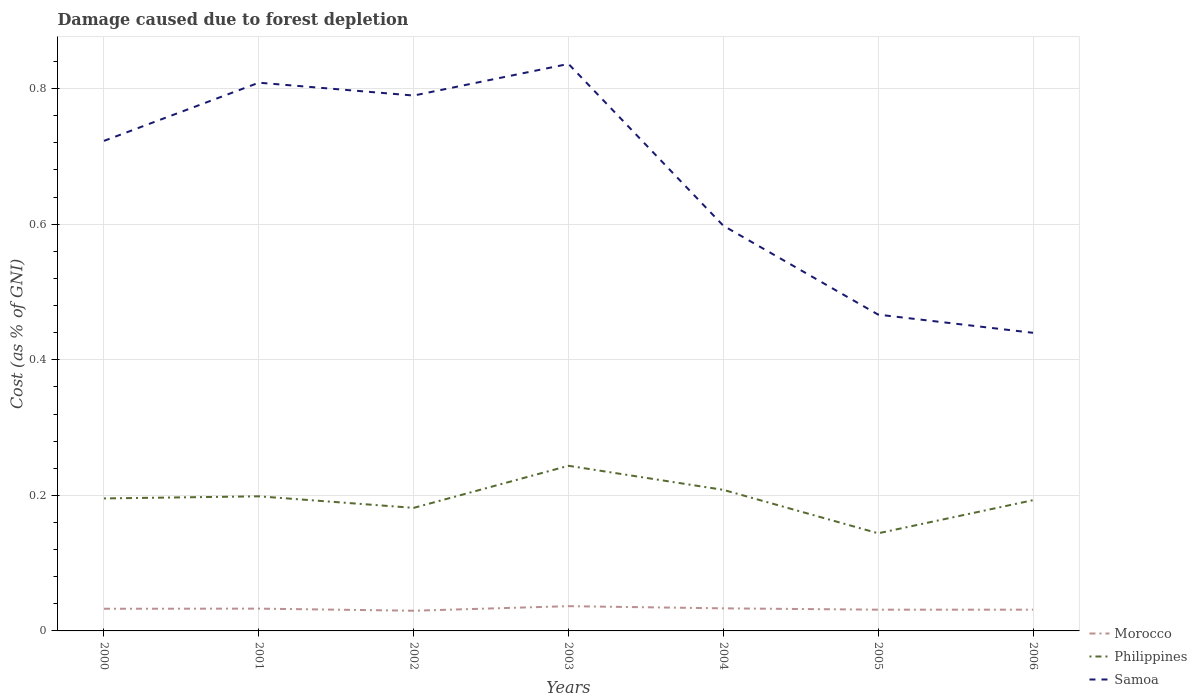Across all years, what is the maximum cost of damage caused due to forest depletion in Morocco?
Provide a succinct answer. 0.03. What is the total cost of damage caused due to forest depletion in Philippines in the graph?
Ensure brevity in your answer.  -0.05. What is the difference between the highest and the second highest cost of damage caused due to forest depletion in Philippines?
Provide a short and direct response. 0.1. What is the difference between the highest and the lowest cost of damage caused due to forest depletion in Morocco?
Offer a terse response. 4. How many years are there in the graph?
Give a very brief answer. 7. Does the graph contain any zero values?
Ensure brevity in your answer.  No. How many legend labels are there?
Keep it short and to the point. 3. How are the legend labels stacked?
Offer a very short reply. Vertical. What is the title of the graph?
Offer a terse response. Damage caused due to forest depletion. What is the label or title of the X-axis?
Ensure brevity in your answer.  Years. What is the label or title of the Y-axis?
Offer a very short reply. Cost (as % of GNI). What is the Cost (as % of GNI) of Morocco in 2000?
Keep it short and to the point. 0.03. What is the Cost (as % of GNI) in Philippines in 2000?
Keep it short and to the point. 0.2. What is the Cost (as % of GNI) in Samoa in 2000?
Ensure brevity in your answer.  0.72. What is the Cost (as % of GNI) in Morocco in 2001?
Your response must be concise. 0.03. What is the Cost (as % of GNI) in Philippines in 2001?
Your answer should be very brief. 0.2. What is the Cost (as % of GNI) in Samoa in 2001?
Your answer should be very brief. 0.81. What is the Cost (as % of GNI) in Morocco in 2002?
Provide a succinct answer. 0.03. What is the Cost (as % of GNI) in Philippines in 2002?
Your response must be concise. 0.18. What is the Cost (as % of GNI) in Samoa in 2002?
Your response must be concise. 0.79. What is the Cost (as % of GNI) of Morocco in 2003?
Make the answer very short. 0.04. What is the Cost (as % of GNI) of Philippines in 2003?
Provide a short and direct response. 0.24. What is the Cost (as % of GNI) of Samoa in 2003?
Offer a very short reply. 0.84. What is the Cost (as % of GNI) of Morocco in 2004?
Make the answer very short. 0.03. What is the Cost (as % of GNI) of Philippines in 2004?
Offer a terse response. 0.21. What is the Cost (as % of GNI) of Samoa in 2004?
Make the answer very short. 0.6. What is the Cost (as % of GNI) of Morocco in 2005?
Provide a succinct answer. 0.03. What is the Cost (as % of GNI) of Philippines in 2005?
Your answer should be very brief. 0.14. What is the Cost (as % of GNI) in Samoa in 2005?
Ensure brevity in your answer.  0.47. What is the Cost (as % of GNI) in Morocco in 2006?
Offer a very short reply. 0.03. What is the Cost (as % of GNI) in Philippines in 2006?
Your response must be concise. 0.19. What is the Cost (as % of GNI) of Samoa in 2006?
Ensure brevity in your answer.  0.44. Across all years, what is the maximum Cost (as % of GNI) of Morocco?
Give a very brief answer. 0.04. Across all years, what is the maximum Cost (as % of GNI) of Philippines?
Your answer should be compact. 0.24. Across all years, what is the maximum Cost (as % of GNI) in Samoa?
Keep it short and to the point. 0.84. Across all years, what is the minimum Cost (as % of GNI) in Morocco?
Your response must be concise. 0.03. Across all years, what is the minimum Cost (as % of GNI) in Philippines?
Keep it short and to the point. 0.14. Across all years, what is the minimum Cost (as % of GNI) of Samoa?
Keep it short and to the point. 0.44. What is the total Cost (as % of GNI) in Morocco in the graph?
Provide a short and direct response. 0.23. What is the total Cost (as % of GNI) of Philippines in the graph?
Provide a short and direct response. 1.36. What is the total Cost (as % of GNI) of Samoa in the graph?
Your response must be concise. 4.66. What is the difference between the Cost (as % of GNI) in Morocco in 2000 and that in 2001?
Offer a very short reply. -0. What is the difference between the Cost (as % of GNI) in Philippines in 2000 and that in 2001?
Ensure brevity in your answer.  -0. What is the difference between the Cost (as % of GNI) in Samoa in 2000 and that in 2001?
Offer a terse response. -0.09. What is the difference between the Cost (as % of GNI) in Morocco in 2000 and that in 2002?
Keep it short and to the point. 0. What is the difference between the Cost (as % of GNI) in Philippines in 2000 and that in 2002?
Make the answer very short. 0.01. What is the difference between the Cost (as % of GNI) in Samoa in 2000 and that in 2002?
Your response must be concise. -0.07. What is the difference between the Cost (as % of GNI) in Morocco in 2000 and that in 2003?
Offer a very short reply. -0. What is the difference between the Cost (as % of GNI) in Philippines in 2000 and that in 2003?
Offer a terse response. -0.05. What is the difference between the Cost (as % of GNI) of Samoa in 2000 and that in 2003?
Provide a short and direct response. -0.11. What is the difference between the Cost (as % of GNI) in Morocco in 2000 and that in 2004?
Offer a terse response. -0. What is the difference between the Cost (as % of GNI) of Philippines in 2000 and that in 2004?
Offer a very short reply. -0.01. What is the difference between the Cost (as % of GNI) in Samoa in 2000 and that in 2004?
Make the answer very short. 0.13. What is the difference between the Cost (as % of GNI) in Morocco in 2000 and that in 2005?
Offer a very short reply. 0. What is the difference between the Cost (as % of GNI) of Philippines in 2000 and that in 2005?
Offer a very short reply. 0.05. What is the difference between the Cost (as % of GNI) in Samoa in 2000 and that in 2005?
Ensure brevity in your answer.  0.26. What is the difference between the Cost (as % of GNI) of Morocco in 2000 and that in 2006?
Keep it short and to the point. 0. What is the difference between the Cost (as % of GNI) of Philippines in 2000 and that in 2006?
Give a very brief answer. 0. What is the difference between the Cost (as % of GNI) in Samoa in 2000 and that in 2006?
Your answer should be very brief. 0.28. What is the difference between the Cost (as % of GNI) of Morocco in 2001 and that in 2002?
Give a very brief answer. 0. What is the difference between the Cost (as % of GNI) in Philippines in 2001 and that in 2002?
Provide a succinct answer. 0.02. What is the difference between the Cost (as % of GNI) in Samoa in 2001 and that in 2002?
Provide a succinct answer. 0.02. What is the difference between the Cost (as % of GNI) in Morocco in 2001 and that in 2003?
Your answer should be compact. -0. What is the difference between the Cost (as % of GNI) in Philippines in 2001 and that in 2003?
Ensure brevity in your answer.  -0.04. What is the difference between the Cost (as % of GNI) in Samoa in 2001 and that in 2003?
Offer a terse response. -0.03. What is the difference between the Cost (as % of GNI) in Morocco in 2001 and that in 2004?
Your answer should be compact. -0. What is the difference between the Cost (as % of GNI) of Philippines in 2001 and that in 2004?
Give a very brief answer. -0.01. What is the difference between the Cost (as % of GNI) of Samoa in 2001 and that in 2004?
Your response must be concise. 0.21. What is the difference between the Cost (as % of GNI) of Morocco in 2001 and that in 2005?
Your response must be concise. 0. What is the difference between the Cost (as % of GNI) in Philippines in 2001 and that in 2005?
Provide a succinct answer. 0.05. What is the difference between the Cost (as % of GNI) of Samoa in 2001 and that in 2005?
Give a very brief answer. 0.34. What is the difference between the Cost (as % of GNI) in Morocco in 2001 and that in 2006?
Offer a terse response. 0. What is the difference between the Cost (as % of GNI) in Philippines in 2001 and that in 2006?
Your response must be concise. 0.01. What is the difference between the Cost (as % of GNI) in Samoa in 2001 and that in 2006?
Provide a short and direct response. 0.37. What is the difference between the Cost (as % of GNI) in Morocco in 2002 and that in 2003?
Your answer should be very brief. -0.01. What is the difference between the Cost (as % of GNI) of Philippines in 2002 and that in 2003?
Provide a succinct answer. -0.06. What is the difference between the Cost (as % of GNI) in Samoa in 2002 and that in 2003?
Provide a succinct answer. -0.05. What is the difference between the Cost (as % of GNI) in Morocco in 2002 and that in 2004?
Provide a succinct answer. -0. What is the difference between the Cost (as % of GNI) of Philippines in 2002 and that in 2004?
Ensure brevity in your answer.  -0.03. What is the difference between the Cost (as % of GNI) of Samoa in 2002 and that in 2004?
Make the answer very short. 0.19. What is the difference between the Cost (as % of GNI) in Morocco in 2002 and that in 2005?
Offer a terse response. -0. What is the difference between the Cost (as % of GNI) in Philippines in 2002 and that in 2005?
Offer a very short reply. 0.04. What is the difference between the Cost (as % of GNI) of Samoa in 2002 and that in 2005?
Offer a terse response. 0.32. What is the difference between the Cost (as % of GNI) of Morocco in 2002 and that in 2006?
Keep it short and to the point. -0. What is the difference between the Cost (as % of GNI) in Philippines in 2002 and that in 2006?
Keep it short and to the point. -0.01. What is the difference between the Cost (as % of GNI) of Morocco in 2003 and that in 2004?
Offer a very short reply. 0. What is the difference between the Cost (as % of GNI) in Philippines in 2003 and that in 2004?
Offer a very short reply. 0.04. What is the difference between the Cost (as % of GNI) of Samoa in 2003 and that in 2004?
Provide a short and direct response. 0.24. What is the difference between the Cost (as % of GNI) of Morocco in 2003 and that in 2005?
Offer a terse response. 0.01. What is the difference between the Cost (as % of GNI) in Philippines in 2003 and that in 2005?
Your answer should be very brief. 0.1. What is the difference between the Cost (as % of GNI) of Samoa in 2003 and that in 2005?
Keep it short and to the point. 0.37. What is the difference between the Cost (as % of GNI) of Morocco in 2003 and that in 2006?
Make the answer very short. 0.01. What is the difference between the Cost (as % of GNI) of Philippines in 2003 and that in 2006?
Your response must be concise. 0.05. What is the difference between the Cost (as % of GNI) of Samoa in 2003 and that in 2006?
Your answer should be compact. 0.4. What is the difference between the Cost (as % of GNI) in Morocco in 2004 and that in 2005?
Offer a very short reply. 0. What is the difference between the Cost (as % of GNI) of Philippines in 2004 and that in 2005?
Keep it short and to the point. 0.06. What is the difference between the Cost (as % of GNI) in Samoa in 2004 and that in 2005?
Make the answer very short. 0.13. What is the difference between the Cost (as % of GNI) of Morocco in 2004 and that in 2006?
Your answer should be compact. 0. What is the difference between the Cost (as % of GNI) in Philippines in 2004 and that in 2006?
Provide a short and direct response. 0.02. What is the difference between the Cost (as % of GNI) of Samoa in 2004 and that in 2006?
Your answer should be compact. 0.16. What is the difference between the Cost (as % of GNI) of Morocco in 2005 and that in 2006?
Ensure brevity in your answer.  0. What is the difference between the Cost (as % of GNI) in Philippines in 2005 and that in 2006?
Provide a succinct answer. -0.05. What is the difference between the Cost (as % of GNI) of Samoa in 2005 and that in 2006?
Your response must be concise. 0.03. What is the difference between the Cost (as % of GNI) of Morocco in 2000 and the Cost (as % of GNI) of Philippines in 2001?
Offer a terse response. -0.17. What is the difference between the Cost (as % of GNI) in Morocco in 2000 and the Cost (as % of GNI) in Samoa in 2001?
Make the answer very short. -0.78. What is the difference between the Cost (as % of GNI) of Philippines in 2000 and the Cost (as % of GNI) of Samoa in 2001?
Offer a very short reply. -0.61. What is the difference between the Cost (as % of GNI) of Morocco in 2000 and the Cost (as % of GNI) of Philippines in 2002?
Make the answer very short. -0.15. What is the difference between the Cost (as % of GNI) in Morocco in 2000 and the Cost (as % of GNI) in Samoa in 2002?
Your answer should be compact. -0.76. What is the difference between the Cost (as % of GNI) of Philippines in 2000 and the Cost (as % of GNI) of Samoa in 2002?
Your response must be concise. -0.59. What is the difference between the Cost (as % of GNI) in Morocco in 2000 and the Cost (as % of GNI) in Philippines in 2003?
Offer a very short reply. -0.21. What is the difference between the Cost (as % of GNI) in Morocco in 2000 and the Cost (as % of GNI) in Samoa in 2003?
Provide a short and direct response. -0.8. What is the difference between the Cost (as % of GNI) of Philippines in 2000 and the Cost (as % of GNI) of Samoa in 2003?
Give a very brief answer. -0.64. What is the difference between the Cost (as % of GNI) of Morocco in 2000 and the Cost (as % of GNI) of Philippines in 2004?
Offer a terse response. -0.18. What is the difference between the Cost (as % of GNI) of Morocco in 2000 and the Cost (as % of GNI) of Samoa in 2004?
Your answer should be very brief. -0.57. What is the difference between the Cost (as % of GNI) in Philippines in 2000 and the Cost (as % of GNI) in Samoa in 2004?
Your answer should be very brief. -0.4. What is the difference between the Cost (as % of GNI) of Morocco in 2000 and the Cost (as % of GNI) of Philippines in 2005?
Keep it short and to the point. -0.11. What is the difference between the Cost (as % of GNI) of Morocco in 2000 and the Cost (as % of GNI) of Samoa in 2005?
Provide a succinct answer. -0.43. What is the difference between the Cost (as % of GNI) in Philippines in 2000 and the Cost (as % of GNI) in Samoa in 2005?
Ensure brevity in your answer.  -0.27. What is the difference between the Cost (as % of GNI) of Morocco in 2000 and the Cost (as % of GNI) of Philippines in 2006?
Make the answer very short. -0.16. What is the difference between the Cost (as % of GNI) of Morocco in 2000 and the Cost (as % of GNI) of Samoa in 2006?
Provide a succinct answer. -0.41. What is the difference between the Cost (as % of GNI) in Philippines in 2000 and the Cost (as % of GNI) in Samoa in 2006?
Keep it short and to the point. -0.24. What is the difference between the Cost (as % of GNI) in Morocco in 2001 and the Cost (as % of GNI) in Philippines in 2002?
Your answer should be very brief. -0.15. What is the difference between the Cost (as % of GNI) in Morocco in 2001 and the Cost (as % of GNI) in Samoa in 2002?
Provide a short and direct response. -0.76. What is the difference between the Cost (as % of GNI) of Philippines in 2001 and the Cost (as % of GNI) of Samoa in 2002?
Offer a terse response. -0.59. What is the difference between the Cost (as % of GNI) of Morocco in 2001 and the Cost (as % of GNI) of Philippines in 2003?
Your answer should be very brief. -0.21. What is the difference between the Cost (as % of GNI) of Morocco in 2001 and the Cost (as % of GNI) of Samoa in 2003?
Offer a very short reply. -0.8. What is the difference between the Cost (as % of GNI) of Philippines in 2001 and the Cost (as % of GNI) of Samoa in 2003?
Provide a short and direct response. -0.64. What is the difference between the Cost (as % of GNI) in Morocco in 2001 and the Cost (as % of GNI) in Philippines in 2004?
Offer a very short reply. -0.18. What is the difference between the Cost (as % of GNI) in Morocco in 2001 and the Cost (as % of GNI) in Samoa in 2004?
Provide a succinct answer. -0.56. What is the difference between the Cost (as % of GNI) of Philippines in 2001 and the Cost (as % of GNI) of Samoa in 2004?
Your answer should be compact. -0.4. What is the difference between the Cost (as % of GNI) in Morocco in 2001 and the Cost (as % of GNI) in Philippines in 2005?
Offer a very short reply. -0.11. What is the difference between the Cost (as % of GNI) in Morocco in 2001 and the Cost (as % of GNI) in Samoa in 2005?
Your answer should be compact. -0.43. What is the difference between the Cost (as % of GNI) in Philippines in 2001 and the Cost (as % of GNI) in Samoa in 2005?
Keep it short and to the point. -0.27. What is the difference between the Cost (as % of GNI) of Morocco in 2001 and the Cost (as % of GNI) of Philippines in 2006?
Your response must be concise. -0.16. What is the difference between the Cost (as % of GNI) in Morocco in 2001 and the Cost (as % of GNI) in Samoa in 2006?
Your answer should be very brief. -0.41. What is the difference between the Cost (as % of GNI) in Philippines in 2001 and the Cost (as % of GNI) in Samoa in 2006?
Ensure brevity in your answer.  -0.24. What is the difference between the Cost (as % of GNI) in Morocco in 2002 and the Cost (as % of GNI) in Philippines in 2003?
Your answer should be very brief. -0.21. What is the difference between the Cost (as % of GNI) of Morocco in 2002 and the Cost (as % of GNI) of Samoa in 2003?
Offer a terse response. -0.81. What is the difference between the Cost (as % of GNI) in Philippines in 2002 and the Cost (as % of GNI) in Samoa in 2003?
Offer a very short reply. -0.65. What is the difference between the Cost (as % of GNI) of Morocco in 2002 and the Cost (as % of GNI) of Philippines in 2004?
Provide a succinct answer. -0.18. What is the difference between the Cost (as % of GNI) of Morocco in 2002 and the Cost (as % of GNI) of Samoa in 2004?
Your answer should be compact. -0.57. What is the difference between the Cost (as % of GNI) of Philippines in 2002 and the Cost (as % of GNI) of Samoa in 2004?
Keep it short and to the point. -0.42. What is the difference between the Cost (as % of GNI) of Morocco in 2002 and the Cost (as % of GNI) of Philippines in 2005?
Offer a very short reply. -0.11. What is the difference between the Cost (as % of GNI) in Morocco in 2002 and the Cost (as % of GNI) in Samoa in 2005?
Offer a terse response. -0.44. What is the difference between the Cost (as % of GNI) in Philippines in 2002 and the Cost (as % of GNI) in Samoa in 2005?
Keep it short and to the point. -0.29. What is the difference between the Cost (as % of GNI) of Morocco in 2002 and the Cost (as % of GNI) of Philippines in 2006?
Your answer should be very brief. -0.16. What is the difference between the Cost (as % of GNI) in Morocco in 2002 and the Cost (as % of GNI) in Samoa in 2006?
Provide a short and direct response. -0.41. What is the difference between the Cost (as % of GNI) in Philippines in 2002 and the Cost (as % of GNI) in Samoa in 2006?
Your answer should be compact. -0.26. What is the difference between the Cost (as % of GNI) of Morocco in 2003 and the Cost (as % of GNI) of Philippines in 2004?
Your answer should be compact. -0.17. What is the difference between the Cost (as % of GNI) in Morocco in 2003 and the Cost (as % of GNI) in Samoa in 2004?
Offer a terse response. -0.56. What is the difference between the Cost (as % of GNI) of Philippines in 2003 and the Cost (as % of GNI) of Samoa in 2004?
Your answer should be very brief. -0.35. What is the difference between the Cost (as % of GNI) in Morocco in 2003 and the Cost (as % of GNI) in Philippines in 2005?
Your answer should be compact. -0.11. What is the difference between the Cost (as % of GNI) of Morocco in 2003 and the Cost (as % of GNI) of Samoa in 2005?
Your response must be concise. -0.43. What is the difference between the Cost (as % of GNI) of Philippines in 2003 and the Cost (as % of GNI) of Samoa in 2005?
Provide a succinct answer. -0.22. What is the difference between the Cost (as % of GNI) of Morocco in 2003 and the Cost (as % of GNI) of Philippines in 2006?
Ensure brevity in your answer.  -0.16. What is the difference between the Cost (as % of GNI) of Morocco in 2003 and the Cost (as % of GNI) of Samoa in 2006?
Offer a terse response. -0.4. What is the difference between the Cost (as % of GNI) of Philippines in 2003 and the Cost (as % of GNI) of Samoa in 2006?
Your response must be concise. -0.2. What is the difference between the Cost (as % of GNI) of Morocco in 2004 and the Cost (as % of GNI) of Philippines in 2005?
Your answer should be compact. -0.11. What is the difference between the Cost (as % of GNI) in Morocco in 2004 and the Cost (as % of GNI) in Samoa in 2005?
Keep it short and to the point. -0.43. What is the difference between the Cost (as % of GNI) in Philippines in 2004 and the Cost (as % of GNI) in Samoa in 2005?
Ensure brevity in your answer.  -0.26. What is the difference between the Cost (as % of GNI) in Morocco in 2004 and the Cost (as % of GNI) in Philippines in 2006?
Keep it short and to the point. -0.16. What is the difference between the Cost (as % of GNI) in Morocco in 2004 and the Cost (as % of GNI) in Samoa in 2006?
Give a very brief answer. -0.41. What is the difference between the Cost (as % of GNI) of Philippines in 2004 and the Cost (as % of GNI) of Samoa in 2006?
Your answer should be very brief. -0.23. What is the difference between the Cost (as % of GNI) of Morocco in 2005 and the Cost (as % of GNI) of Philippines in 2006?
Your answer should be very brief. -0.16. What is the difference between the Cost (as % of GNI) in Morocco in 2005 and the Cost (as % of GNI) in Samoa in 2006?
Offer a very short reply. -0.41. What is the difference between the Cost (as % of GNI) of Philippines in 2005 and the Cost (as % of GNI) of Samoa in 2006?
Your answer should be compact. -0.3. What is the average Cost (as % of GNI) in Morocco per year?
Give a very brief answer. 0.03. What is the average Cost (as % of GNI) of Philippines per year?
Ensure brevity in your answer.  0.19. What is the average Cost (as % of GNI) in Samoa per year?
Provide a succinct answer. 0.67. In the year 2000, what is the difference between the Cost (as % of GNI) of Morocco and Cost (as % of GNI) of Philippines?
Keep it short and to the point. -0.16. In the year 2000, what is the difference between the Cost (as % of GNI) in Morocco and Cost (as % of GNI) in Samoa?
Provide a succinct answer. -0.69. In the year 2000, what is the difference between the Cost (as % of GNI) in Philippines and Cost (as % of GNI) in Samoa?
Make the answer very short. -0.53. In the year 2001, what is the difference between the Cost (as % of GNI) in Morocco and Cost (as % of GNI) in Philippines?
Make the answer very short. -0.17. In the year 2001, what is the difference between the Cost (as % of GNI) in Morocco and Cost (as % of GNI) in Samoa?
Give a very brief answer. -0.78. In the year 2001, what is the difference between the Cost (as % of GNI) of Philippines and Cost (as % of GNI) of Samoa?
Your answer should be very brief. -0.61. In the year 2002, what is the difference between the Cost (as % of GNI) in Morocco and Cost (as % of GNI) in Philippines?
Your answer should be compact. -0.15. In the year 2002, what is the difference between the Cost (as % of GNI) in Morocco and Cost (as % of GNI) in Samoa?
Make the answer very short. -0.76. In the year 2002, what is the difference between the Cost (as % of GNI) in Philippines and Cost (as % of GNI) in Samoa?
Provide a succinct answer. -0.61. In the year 2003, what is the difference between the Cost (as % of GNI) in Morocco and Cost (as % of GNI) in Philippines?
Give a very brief answer. -0.21. In the year 2003, what is the difference between the Cost (as % of GNI) in Morocco and Cost (as % of GNI) in Samoa?
Keep it short and to the point. -0.8. In the year 2003, what is the difference between the Cost (as % of GNI) in Philippines and Cost (as % of GNI) in Samoa?
Give a very brief answer. -0.59. In the year 2004, what is the difference between the Cost (as % of GNI) in Morocco and Cost (as % of GNI) in Philippines?
Provide a succinct answer. -0.17. In the year 2004, what is the difference between the Cost (as % of GNI) of Morocco and Cost (as % of GNI) of Samoa?
Give a very brief answer. -0.56. In the year 2004, what is the difference between the Cost (as % of GNI) in Philippines and Cost (as % of GNI) in Samoa?
Provide a short and direct response. -0.39. In the year 2005, what is the difference between the Cost (as % of GNI) in Morocco and Cost (as % of GNI) in Philippines?
Ensure brevity in your answer.  -0.11. In the year 2005, what is the difference between the Cost (as % of GNI) in Morocco and Cost (as % of GNI) in Samoa?
Give a very brief answer. -0.44. In the year 2005, what is the difference between the Cost (as % of GNI) of Philippines and Cost (as % of GNI) of Samoa?
Give a very brief answer. -0.32. In the year 2006, what is the difference between the Cost (as % of GNI) of Morocco and Cost (as % of GNI) of Philippines?
Offer a very short reply. -0.16. In the year 2006, what is the difference between the Cost (as % of GNI) of Morocco and Cost (as % of GNI) of Samoa?
Keep it short and to the point. -0.41. In the year 2006, what is the difference between the Cost (as % of GNI) in Philippines and Cost (as % of GNI) in Samoa?
Your answer should be very brief. -0.25. What is the ratio of the Cost (as % of GNI) in Morocco in 2000 to that in 2001?
Offer a very short reply. 0.99. What is the ratio of the Cost (as % of GNI) in Philippines in 2000 to that in 2001?
Give a very brief answer. 0.98. What is the ratio of the Cost (as % of GNI) of Samoa in 2000 to that in 2001?
Make the answer very short. 0.89. What is the ratio of the Cost (as % of GNI) of Morocco in 2000 to that in 2002?
Offer a very short reply. 1.1. What is the ratio of the Cost (as % of GNI) of Philippines in 2000 to that in 2002?
Your response must be concise. 1.08. What is the ratio of the Cost (as % of GNI) of Samoa in 2000 to that in 2002?
Keep it short and to the point. 0.92. What is the ratio of the Cost (as % of GNI) of Morocco in 2000 to that in 2003?
Offer a terse response. 0.9. What is the ratio of the Cost (as % of GNI) in Philippines in 2000 to that in 2003?
Offer a very short reply. 0.8. What is the ratio of the Cost (as % of GNI) in Samoa in 2000 to that in 2003?
Provide a short and direct response. 0.86. What is the ratio of the Cost (as % of GNI) in Morocco in 2000 to that in 2004?
Your answer should be compact. 0.98. What is the ratio of the Cost (as % of GNI) in Philippines in 2000 to that in 2004?
Provide a succinct answer. 0.94. What is the ratio of the Cost (as % of GNI) in Samoa in 2000 to that in 2004?
Provide a short and direct response. 1.21. What is the ratio of the Cost (as % of GNI) of Morocco in 2000 to that in 2005?
Ensure brevity in your answer.  1.04. What is the ratio of the Cost (as % of GNI) in Philippines in 2000 to that in 2005?
Offer a very short reply. 1.36. What is the ratio of the Cost (as % of GNI) of Samoa in 2000 to that in 2005?
Your response must be concise. 1.55. What is the ratio of the Cost (as % of GNI) of Morocco in 2000 to that in 2006?
Provide a succinct answer. 1.04. What is the ratio of the Cost (as % of GNI) of Philippines in 2000 to that in 2006?
Ensure brevity in your answer.  1.01. What is the ratio of the Cost (as % of GNI) of Samoa in 2000 to that in 2006?
Offer a terse response. 1.64. What is the ratio of the Cost (as % of GNI) of Morocco in 2001 to that in 2002?
Your answer should be very brief. 1.1. What is the ratio of the Cost (as % of GNI) in Philippines in 2001 to that in 2002?
Keep it short and to the point. 1.09. What is the ratio of the Cost (as % of GNI) in Morocco in 2001 to that in 2003?
Give a very brief answer. 0.9. What is the ratio of the Cost (as % of GNI) in Philippines in 2001 to that in 2003?
Your answer should be very brief. 0.82. What is the ratio of the Cost (as % of GNI) in Samoa in 2001 to that in 2003?
Your answer should be compact. 0.97. What is the ratio of the Cost (as % of GNI) in Morocco in 2001 to that in 2004?
Provide a succinct answer. 0.99. What is the ratio of the Cost (as % of GNI) of Philippines in 2001 to that in 2004?
Provide a succinct answer. 0.95. What is the ratio of the Cost (as % of GNI) in Samoa in 2001 to that in 2004?
Offer a very short reply. 1.35. What is the ratio of the Cost (as % of GNI) of Morocco in 2001 to that in 2005?
Offer a very short reply. 1.05. What is the ratio of the Cost (as % of GNI) of Philippines in 2001 to that in 2005?
Keep it short and to the point. 1.38. What is the ratio of the Cost (as % of GNI) in Samoa in 2001 to that in 2005?
Your answer should be very brief. 1.73. What is the ratio of the Cost (as % of GNI) in Morocco in 2001 to that in 2006?
Your answer should be very brief. 1.05. What is the ratio of the Cost (as % of GNI) in Philippines in 2001 to that in 2006?
Make the answer very short. 1.03. What is the ratio of the Cost (as % of GNI) of Samoa in 2001 to that in 2006?
Your answer should be compact. 1.84. What is the ratio of the Cost (as % of GNI) in Morocco in 2002 to that in 2003?
Provide a succinct answer. 0.82. What is the ratio of the Cost (as % of GNI) in Philippines in 2002 to that in 2003?
Provide a short and direct response. 0.75. What is the ratio of the Cost (as % of GNI) in Samoa in 2002 to that in 2003?
Give a very brief answer. 0.94. What is the ratio of the Cost (as % of GNI) in Morocco in 2002 to that in 2004?
Your answer should be compact. 0.89. What is the ratio of the Cost (as % of GNI) in Philippines in 2002 to that in 2004?
Give a very brief answer. 0.87. What is the ratio of the Cost (as % of GNI) in Samoa in 2002 to that in 2004?
Make the answer very short. 1.32. What is the ratio of the Cost (as % of GNI) of Morocco in 2002 to that in 2005?
Provide a succinct answer. 0.95. What is the ratio of the Cost (as % of GNI) of Philippines in 2002 to that in 2005?
Provide a succinct answer. 1.26. What is the ratio of the Cost (as % of GNI) in Samoa in 2002 to that in 2005?
Your response must be concise. 1.69. What is the ratio of the Cost (as % of GNI) in Morocco in 2002 to that in 2006?
Provide a short and direct response. 0.95. What is the ratio of the Cost (as % of GNI) of Samoa in 2002 to that in 2006?
Provide a succinct answer. 1.8. What is the ratio of the Cost (as % of GNI) in Morocco in 2003 to that in 2004?
Keep it short and to the point. 1.1. What is the ratio of the Cost (as % of GNI) of Philippines in 2003 to that in 2004?
Your response must be concise. 1.17. What is the ratio of the Cost (as % of GNI) in Samoa in 2003 to that in 2004?
Provide a short and direct response. 1.4. What is the ratio of the Cost (as % of GNI) in Morocco in 2003 to that in 2005?
Ensure brevity in your answer.  1.16. What is the ratio of the Cost (as % of GNI) in Philippines in 2003 to that in 2005?
Your answer should be very brief. 1.69. What is the ratio of the Cost (as % of GNI) in Samoa in 2003 to that in 2005?
Offer a very short reply. 1.79. What is the ratio of the Cost (as % of GNI) in Morocco in 2003 to that in 2006?
Make the answer very short. 1.16. What is the ratio of the Cost (as % of GNI) of Philippines in 2003 to that in 2006?
Provide a short and direct response. 1.26. What is the ratio of the Cost (as % of GNI) in Samoa in 2003 to that in 2006?
Make the answer very short. 1.9. What is the ratio of the Cost (as % of GNI) in Philippines in 2004 to that in 2005?
Provide a short and direct response. 1.44. What is the ratio of the Cost (as % of GNI) in Samoa in 2004 to that in 2005?
Offer a terse response. 1.28. What is the ratio of the Cost (as % of GNI) in Morocco in 2004 to that in 2006?
Your answer should be compact. 1.06. What is the ratio of the Cost (as % of GNI) in Philippines in 2004 to that in 2006?
Your answer should be compact. 1.08. What is the ratio of the Cost (as % of GNI) in Samoa in 2004 to that in 2006?
Give a very brief answer. 1.36. What is the ratio of the Cost (as % of GNI) of Philippines in 2005 to that in 2006?
Your answer should be compact. 0.75. What is the ratio of the Cost (as % of GNI) of Samoa in 2005 to that in 2006?
Keep it short and to the point. 1.06. What is the difference between the highest and the second highest Cost (as % of GNI) in Morocco?
Keep it short and to the point. 0. What is the difference between the highest and the second highest Cost (as % of GNI) of Philippines?
Make the answer very short. 0.04. What is the difference between the highest and the second highest Cost (as % of GNI) in Samoa?
Your answer should be compact. 0.03. What is the difference between the highest and the lowest Cost (as % of GNI) of Morocco?
Keep it short and to the point. 0.01. What is the difference between the highest and the lowest Cost (as % of GNI) of Philippines?
Your response must be concise. 0.1. What is the difference between the highest and the lowest Cost (as % of GNI) of Samoa?
Keep it short and to the point. 0.4. 